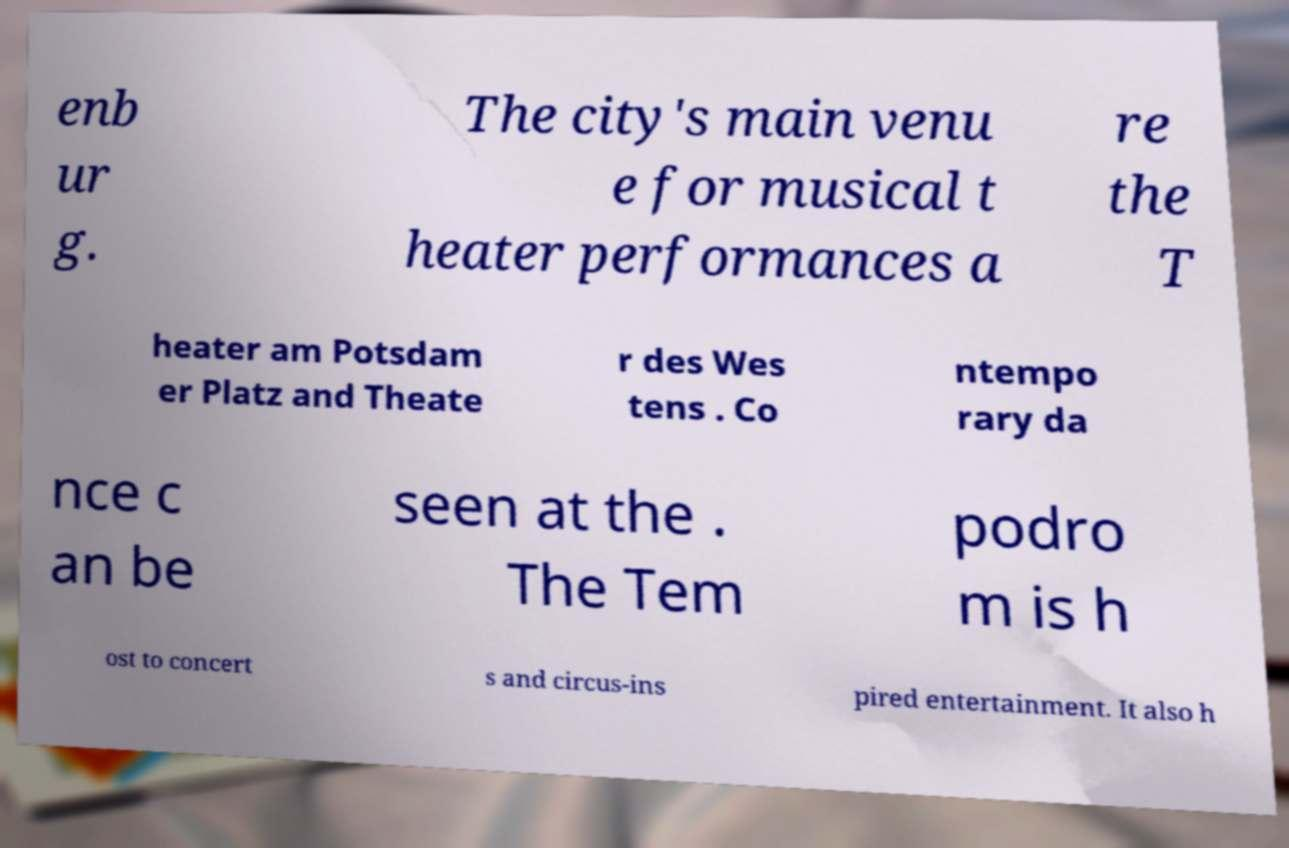I need the written content from this picture converted into text. Can you do that? enb ur g. The city's main venu e for musical t heater performances a re the T heater am Potsdam er Platz and Theate r des Wes tens . Co ntempo rary da nce c an be seen at the . The Tem podro m is h ost to concert s and circus-ins pired entertainment. It also h 